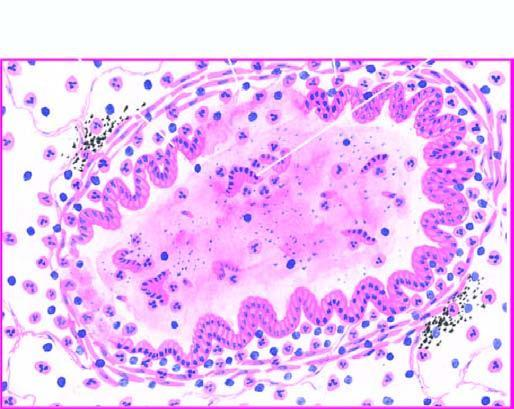s the affected part thickened and infiltrated by acute and chronic inflammatory cells?
Answer the question using a single word or phrase. No 